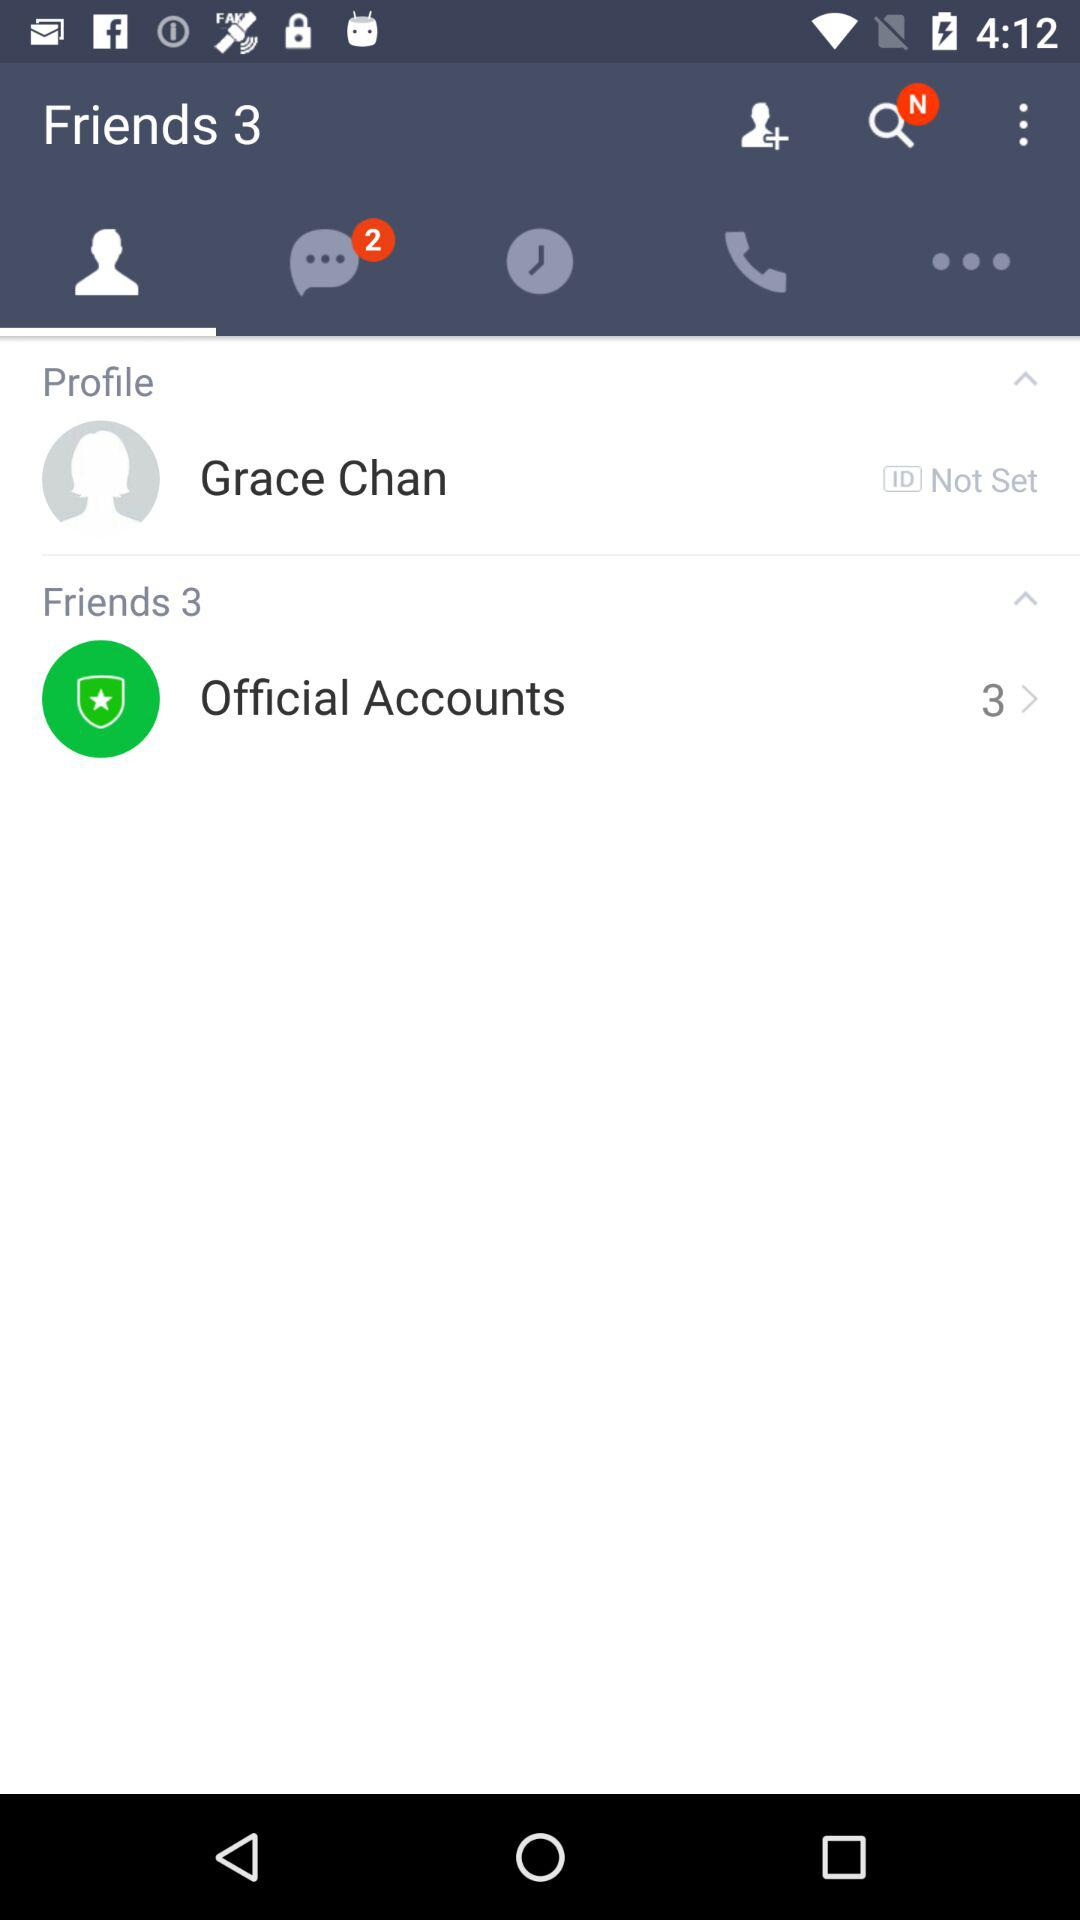How many friends are there?
Answer the question using a single word or phrase. 3 